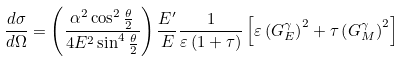<formula> <loc_0><loc_0><loc_500><loc_500>\frac { d \sigma } { d \Omega } = \left ( \frac { \alpha ^ { 2 } \cos ^ { 2 } \frac { \theta } { 2 } } { 4 E ^ { 2 } \sin ^ { 4 } \frac { \theta } { 2 } } \right ) \frac { E ^ { \prime } } { E } \frac { 1 } { \varepsilon \left ( 1 + \tau \right ) } \left [ \varepsilon \left ( G _ { E } ^ { \gamma } \right ) ^ { 2 } + \tau \left ( G _ { M } ^ { \gamma } \right ) ^ { 2 } \right ] \,</formula> 